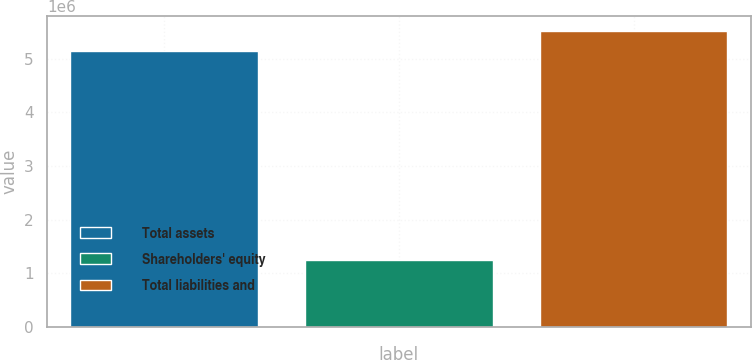<chart> <loc_0><loc_0><loc_500><loc_500><bar_chart><fcel>Total assets<fcel>Shareholders' equity<fcel>Total liabilities and<nl><fcel>5.13778e+06<fcel>1.24592e+06<fcel>5.52696e+06<nl></chart> 